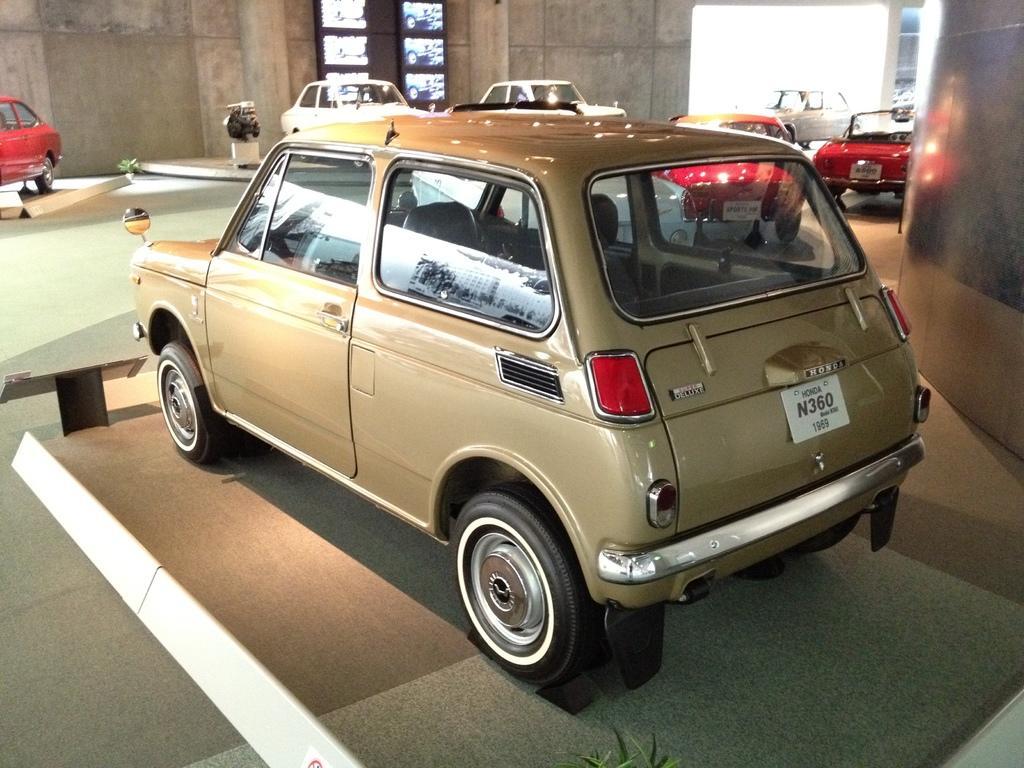Can you describe this image briefly? In this image we can see a group of cars placed on the surface. We can also see some plants, a wall and a window. 